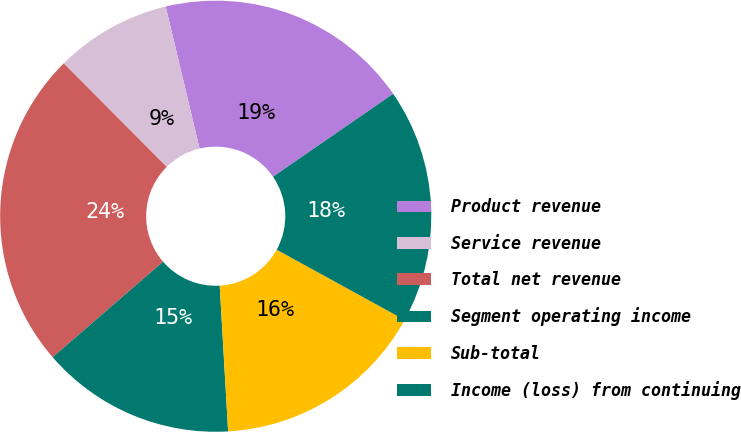Convert chart to OTSL. <chart><loc_0><loc_0><loc_500><loc_500><pie_chart><fcel>Product revenue<fcel>Service revenue<fcel>Total net revenue<fcel>Segment operating income<fcel>Sub-total<fcel>Income (loss) from continuing<nl><fcel>19.12%<fcel>8.73%<fcel>23.89%<fcel>14.57%<fcel>16.09%<fcel>17.6%<nl></chart> 